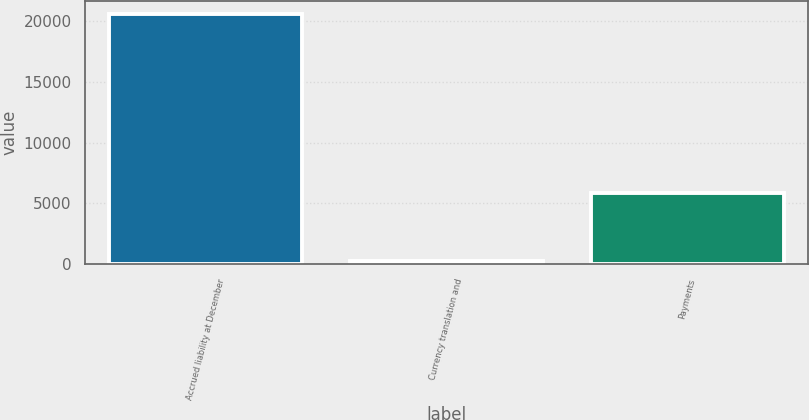Convert chart. <chart><loc_0><loc_0><loc_500><loc_500><bar_chart><fcel>Accrued liability at December<fcel>Currency translation and<fcel>Payments<nl><fcel>20595<fcel>284<fcel>5849<nl></chart> 